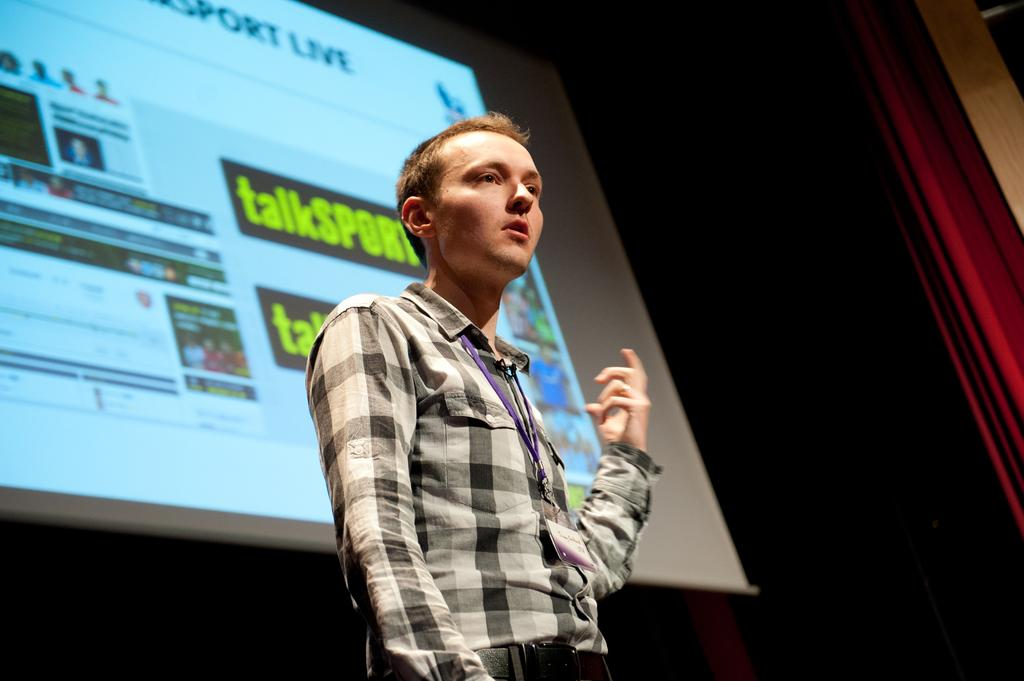What is the main subject in the image? There is a man standing in the image. What can be seen behind the man? There is a screen in the image. What type of decoration is on the right side of the image? There is a red curtain on the right side of the image. How many kittens are sitting on the screen in the image? There are no kittens present in the image. What is the temperature of the cent in the image? There is no cent or any reference to temperature in the image. 